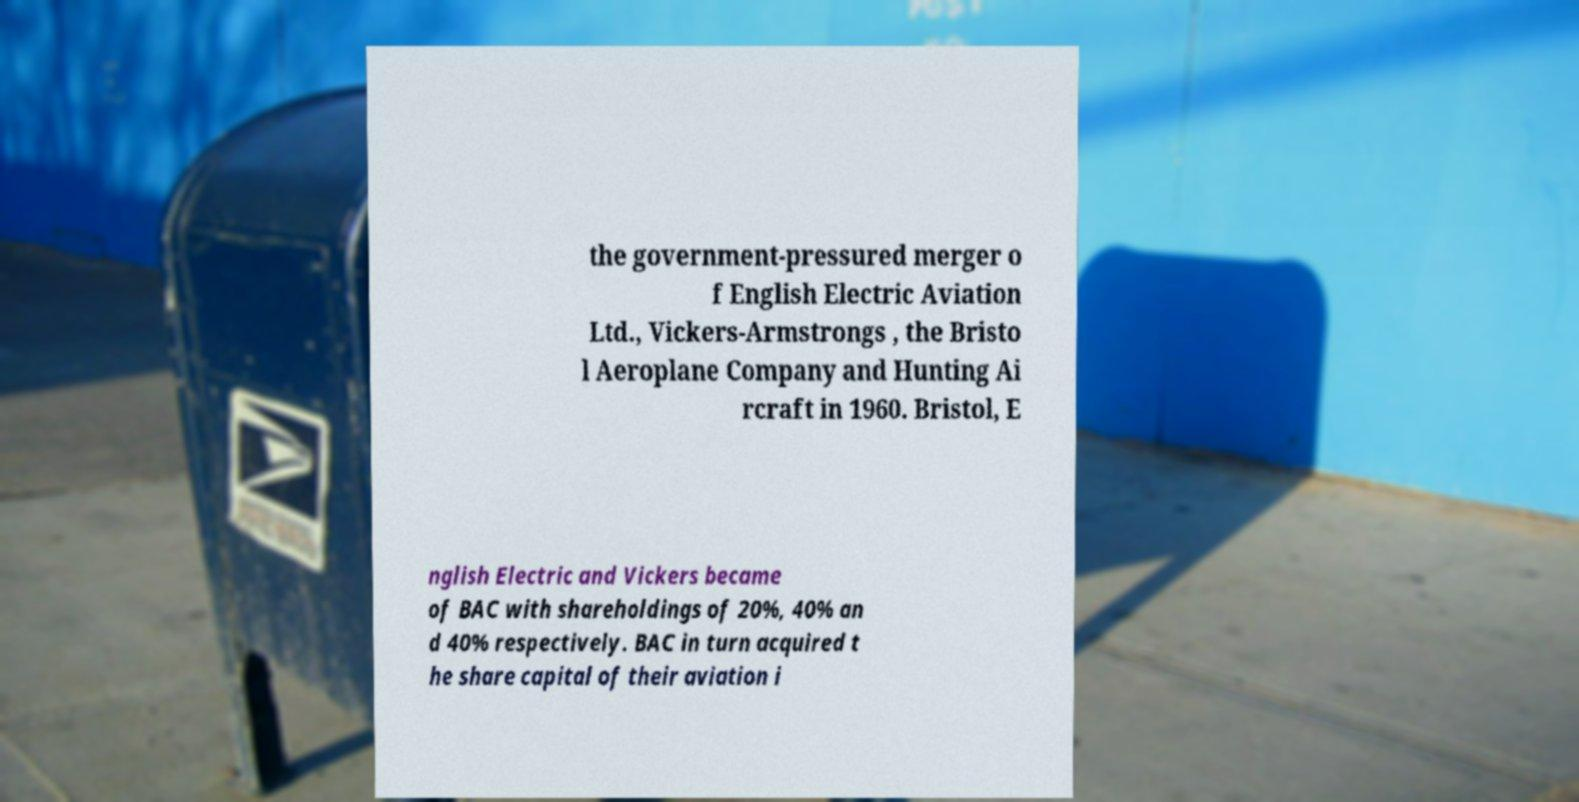What messages or text are displayed in this image? I need them in a readable, typed format. the government-pressured merger o f English Electric Aviation Ltd., Vickers-Armstrongs , the Bristo l Aeroplane Company and Hunting Ai rcraft in 1960. Bristol, E nglish Electric and Vickers became of BAC with shareholdings of 20%, 40% an d 40% respectively. BAC in turn acquired t he share capital of their aviation i 